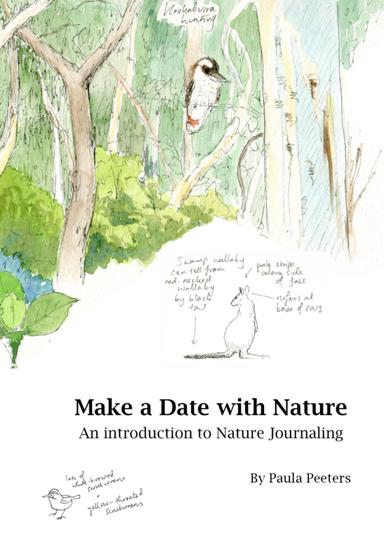What does the book introduce the readers to? The book "Make a Date with Nature" guides readers through the rewarding practice of nature journaling. It encourages observing, documenting, and reflecting on the natural world using various techniques like sketching, writing, and painting, helping readers connect deeply with their surroundings. 